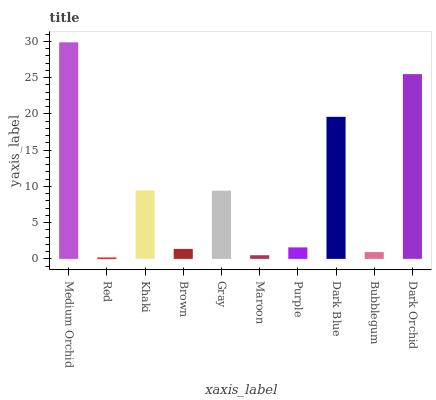Is Red the minimum?
Answer yes or no. Yes. Is Medium Orchid the maximum?
Answer yes or no. Yes. Is Khaki the minimum?
Answer yes or no. No. Is Khaki the maximum?
Answer yes or no. No. Is Khaki greater than Red?
Answer yes or no. Yes. Is Red less than Khaki?
Answer yes or no. Yes. Is Red greater than Khaki?
Answer yes or no. No. Is Khaki less than Red?
Answer yes or no. No. Is Gray the high median?
Answer yes or no. Yes. Is Purple the low median?
Answer yes or no. Yes. Is Bubblegum the high median?
Answer yes or no. No. Is Bubblegum the low median?
Answer yes or no. No. 